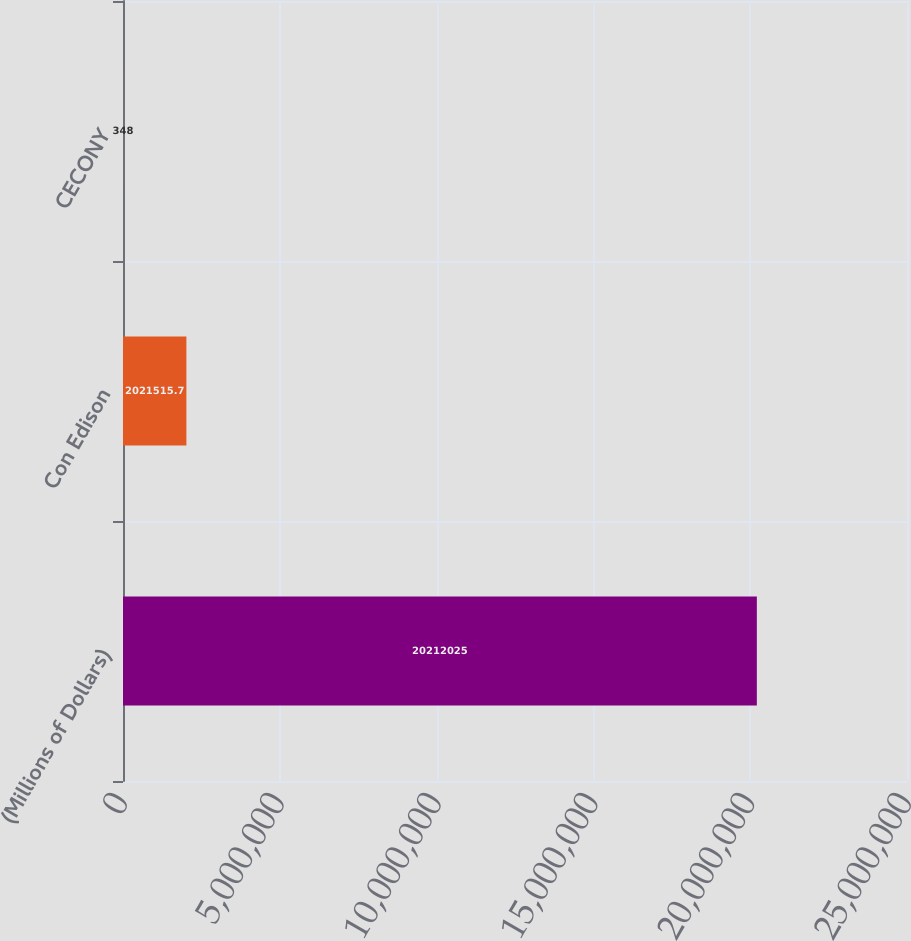<chart> <loc_0><loc_0><loc_500><loc_500><bar_chart><fcel>(Millions of Dollars)<fcel>Con Edison<fcel>CECONY<nl><fcel>2.0212e+07<fcel>2.02152e+06<fcel>348<nl></chart> 